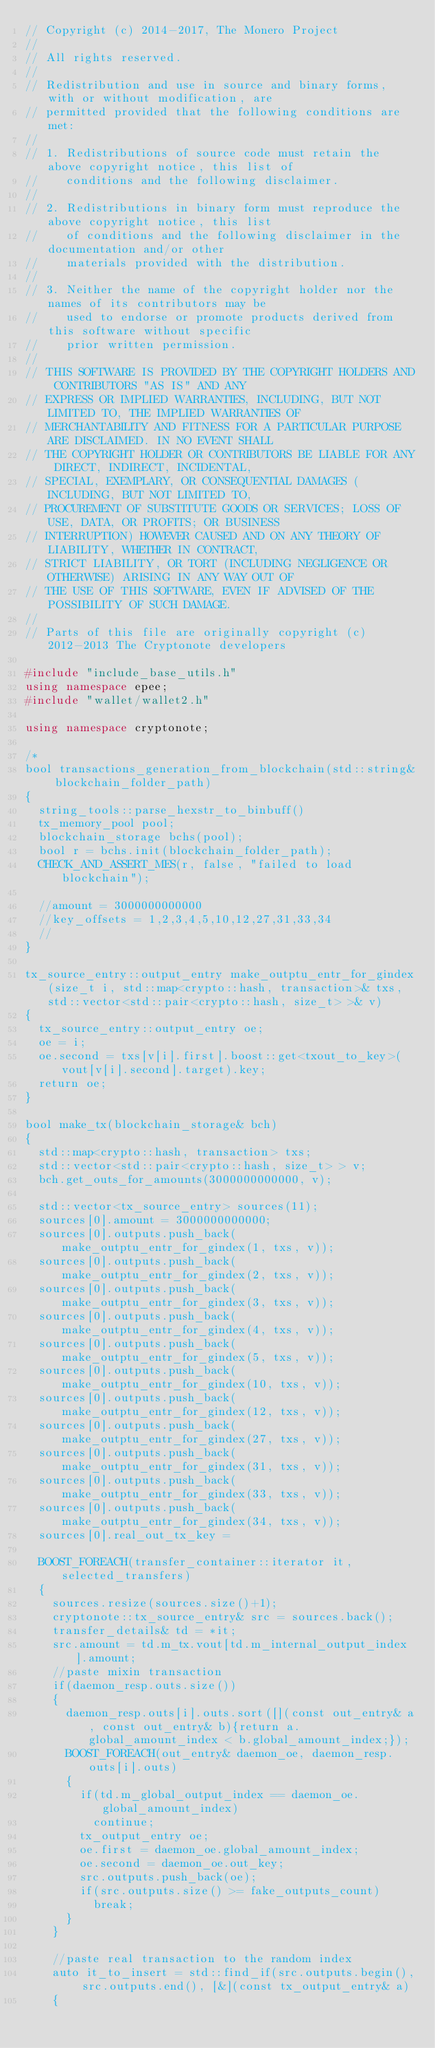Convert code to text. <code><loc_0><loc_0><loc_500><loc_500><_C++_>// Copyright (c) 2014-2017, The Monero Project
//
// All rights reserved.
//
// Redistribution and use in source and binary forms, with or without modification, are
// permitted provided that the following conditions are met:
//
// 1. Redistributions of source code must retain the above copyright notice, this list of
//    conditions and the following disclaimer.
//
// 2. Redistributions in binary form must reproduce the above copyright notice, this list
//    of conditions and the following disclaimer in the documentation and/or other
//    materials provided with the distribution.
//
// 3. Neither the name of the copyright holder nor the names of its contributors may be
//    used to endorse or promote products derived from this software without specific
//    prior written permission.
//
// THIS SOFTWARE IS PROVIDED BY THE COPYRIGHT HOLDERS AND CONTRIBUTORS "AS IS" AND ANY
// EXPRESS OR IMPLIED WARRANTIES, INCLUDING, BUT NOT LIMITED TO, THE IMPLIED WARRANTIES OF
// MERCHANTABILITY AND FITNESS FOR A PARTICULAR PURPOSE ARE DISCLAIMED. IN NO EVENT SHALL
// THE COPYRIGHT HOLDER OR CONTRIBUTORS BE LIABLE FOR ANY DIRECT, INDIRECT, INCIDENTAL,
// SPECIAL, EXEMPLARY, OR CONSEQUENTIAL DAMAGES (INCLUDING, BUT NOT LIMITED TO,
// PROCUREMENT OF SUBSTITUTE GOODS OR SERVICES; LOSS OF USE, DATA, OR PROFITS; OR BUSINESS
// INTERRUPTION) HOWEVER CAUSED AND ON ANY THEORY OF LIABILITY, WHETHER IN CONTRACT,
// STRICT LIABILITY, OR TORT (INCLUDING NEGLIGENCE OR OTHERWISE) ARISING IN ANY WAY OUT OF
// THE USE OF THIS SOFTWARE, EVEN IF ADVISED OF THE POSSIBILITY OF SUCH DAMAGE.
//
// Parts of this file are originally copyright (c) 2012-2013 The Cryptonote developers

#include "include_base_utils.h"
using namespace epee;
#include "wallet/wallet2.h"

using namespace cryptonote;

/*
bool transactions_generation_from_blockchain(std::string& blockchain_folder_path)
{
  string_tools::parse_hexstr_to_binbuff()
  tx_memory_pool pool;
  blockchain_storage bchs(pool);
  bool r = bchs.init(blockchain_folder_path);
  CHECK_AND_ASSERT_MES(r, false, "failed to load blockchain");

  //amount = 3000000000000
  //key_offsets = 1,2,3,4,5,10,12,27,31,33,34
  //
}

tx_source_entry::output_entry make_outptu_entr_for_gindex(size_t i, std::map<crypto::hash, transaction>& txs, std::vector<std::pair<crypto::hash, size_t> >& v)
{
  tx_source_entry::output_entry oe;
  oe = i;
  oe.second = txs[v[i].first].boost::get<txout_to_key>(vout[v[i].second].target).key;
  return oe;
}

bool make_tx(blockchain_storage& bch)
{
  std::map<crypto::hash, transaction> txs;
  std::vector<std::pair<crypto::hash, size_t> > v;
  bch.get_outs_for_amounts(3000000000000, v);

  std::vector<tx_source_entry> sources(11);
  sources[0].amount = 3000000000000;
  sources[0].outputs.push_back(make_outptu_entr_for_gindex(1, txs, v));
  sources[0].outputs.push_back(make_outptu_entr_for_gindex(2, txs, v));
  sources[0].outputs.push_back(make_outptu_entr_for_gindex(3, txs, v));
  sources[0].outputs.push_back(make_outptu_entr_for_gindex(4, txs, v));
  sources[0].outputs.push_back(make_outptu_entr_for_gindex(5, txs, v));
  sources[0].outputs.push_back(make_outptu_entr_for_gindex(10, txs, v));
  sources[0].outputs.push_back(make_outptu_entr_for_gindex(12, txs, v));
  sources[0].outputs.push_back(make_outptu_entr_for_gindex(27, txs, v));
  sources[0].outputs.push_back(make_outptu_entr_for_gindex(31, txs, v));
  sources[0].outputs.push_back(make_outptu_entr_for_gindex(33, txs, v));
  sources[0].outputs.push_back(make_outptu_entr_for_gindex(34, txs, v));
  sources[0].real_out_tx_key =

  BOOST_FOREACH(transfer_container::iterator it, selected_transfers)
  {
    sources.resize(sources.size()+1);
    cryptonote::tx_source_entry& src = sources.back();
    transfer_details& td = *it;
    src.amount = td.m_tx.vout[td.m_internal_output_index].amount;
    //paste mixin transaction
    if(daemon_resp.outs.size())
    {
      daemon_resp.outs[i].outs.sort([](const out_entry& a, const out_entry& b){return a.global_amount_index < b.global_amount_index;});
      BOOST_FOREACH(out_entry& daemon_oe, daemon_resp.outs[i].outs)
      {
        if(td.m_global_output_index == daemon_oe.global_amount_index)
          continue;
        tx_output_entry oe;
        oe.first = daemon_oe.global_amount_index;
        oe.second = daemon_oe.out_key;
        src.outputs.push_back(oe);
        if(src.outputs.size() >= fake_outputs_count)
          break;
      }
    }

    //paste real transaction to the random index
    auto it_to_insert = std::find_if(src.outputs.begin(), src.outputs.end(), [&](const tx_output_entry& a)
    {</code> 